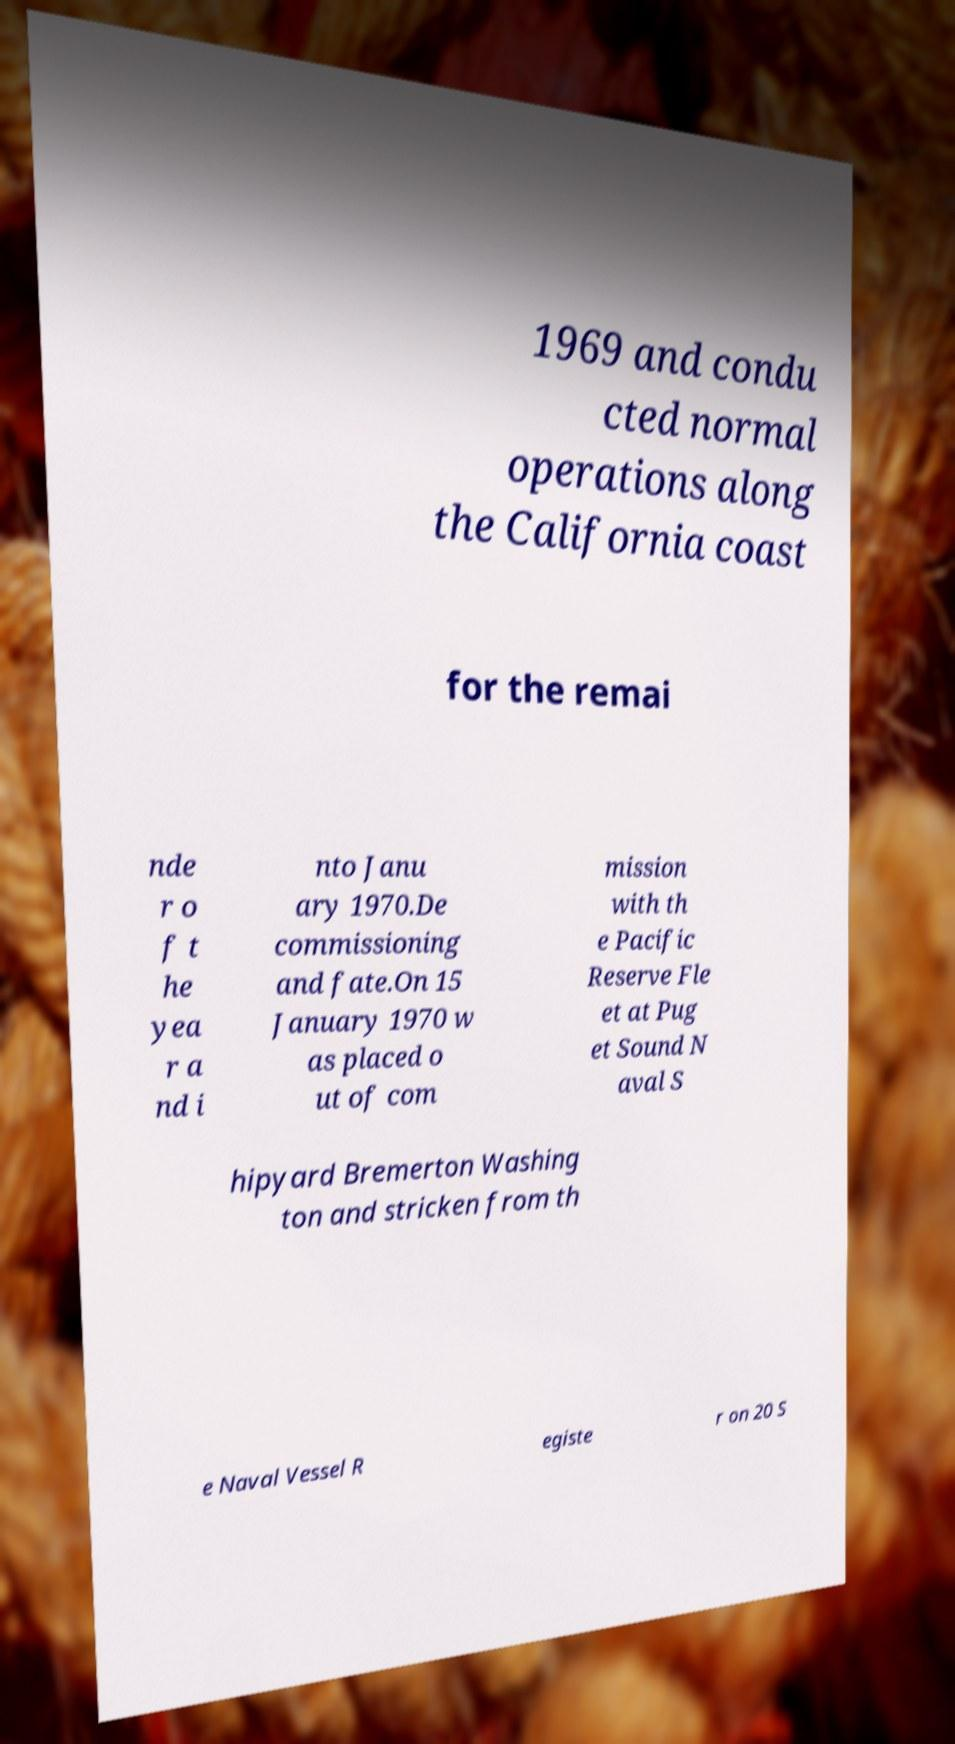Could you assist in decoding the text presented in this image and type it out clearly? 1969 and condu cted normal operations along the California coast for the remai nde r o f t he yea r a nd i nto Janu ary 1970.De commissioning and fate.On 15 January 1970 w as placed o ut of com mission with th e Pacific Reserve Fle et at Pug et Sound N aval S hipyard Bremerton Washing ton and stricken from th e Naval Vessel R egiste r on 20 S 